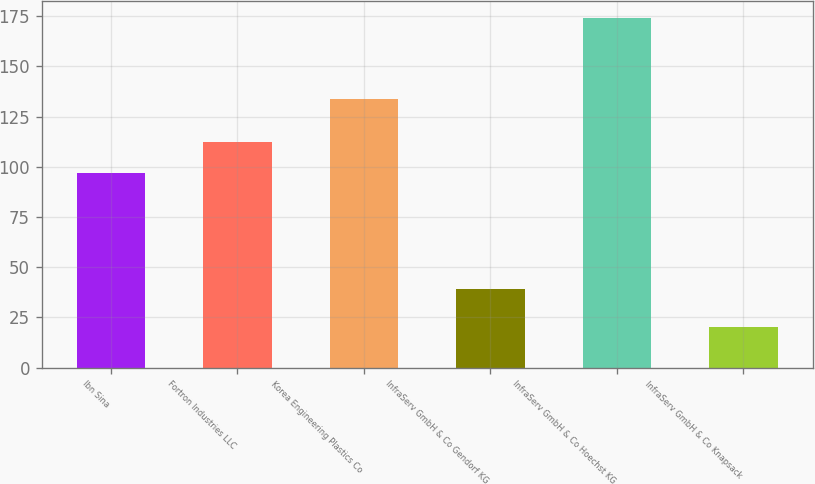Convert chart to OTSL. <chart><loc_0><loc_0><loc_500><loc_500><bar_chart><fcel>Ibn Sina<fcel>Fortron Industries LLC<fcel>Korea Engineering Plastics Co<fcel>InfraServ GmbH & Co Gendorf KG<fcel>InfraServ GmbH & Co Hoechst KG<fcel>InfraServ GmbH & Co Knapsack<nl><fcel>97<fcel>112.4<fcel>134<fcel>39<fcel>174<fcel>20<nl></chart> 